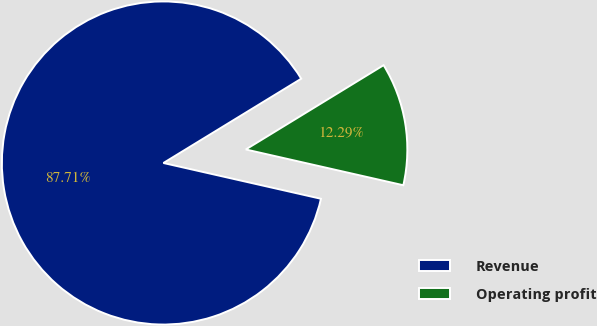Convert chart. <chart><loc_0><loc_0><loc_500><loc_500><pie_chart><fcel>Revenue<fcel>Operating profit<nl><fcel>87.71%<fcel>12.29%<nl></chart> 